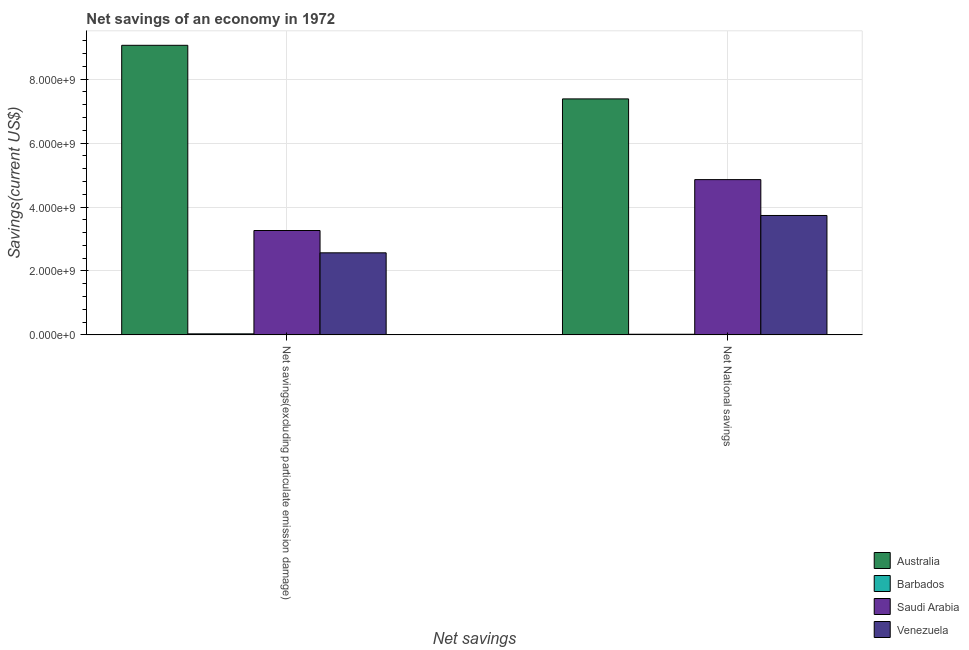How many different coloured bars are there?
Your answer should be compact. 4. How many groups of bars are there?
Provide a succinct answer. 2. Are the number of bars on each tick of the X-axis equal?
Offer a terse response. Yes. How many bars are there on the 2nd tick from the left?
Make the answer very short. 4. How many bars are there on the 2nd tick from the right?
Your response must be concise. 4. What is the label of the 2nd group of bars from the left?
Provide a short and direct response. Net National savings. What is the net savings(excluding particulate emission damage) in Barbados?
Provide a short and direct response. 3.25e+07. Across all countries, what is the maximum net national savings?
Keep it short and to the point. 7.38e+09. Across all countries, what is the minimum net savings(excluding particulate emission damage)?
Offer a terse response. 3.25e+07. In which country was the net savings(excluding particulate emission damage) minimum?
Offer a terse response. Barbados. What is the total net savings(excluding particulate emission damage) in the graph?
Give a very brief answer. 1.49e+1. What is the difference between the net national savings in Australia and that in Venezuela?
Your response must be concise. 3.65e+09. What is the difference between the net national savings in Venezuela and the net savings(excluding particulate emission damage) in Barbados?
Provide a succinct answer. 3.70e+09. What is the average net savings(excluding particulate emission damage) per country?
Provide a succinct answer. 3.73e+09. What is the difference between the net savings(excluding particulate emission damage) and net national savings in Australia?
Offer a terse response. 1.68e+09. In how many countries, is the net savings(excluding particulate emission damage) greater than 8400000000 US$?
Offer a very short reply. 1. What is the ratio of the net national savings in Venezuela to that in Saudi Arabia?
Keep it short and to the point. 0.77. Is the net national savings in Australia less than that in Venezuela?
Your response must be concise. No. In how many countries, is the net national savings greater than the average net national savings taken over all countries?
Give a very brief answer. 2. What does the 3rd bar from the left in Net savings(excluding particulate emission damage) represents?
Your answer should be very brief. Saudi Arabia. What does the 1st bar from the right in Net savings(excluding particulate emission damage) represents?
Your answer should be very brief. Venezuela. How many countries are there in the graph?
Your answer should be compact. 4. What is the difference between two consecutive major ticks on the Y-axis?
Offer a very short reply. 2.00e+09. Are the values on the major ticks of Y-axis written in scientific E-notation?
Provide a succinct answer. Yes. How many legend labels are there?
Your answer should be very brief. 4. What is the title of the graph?
Your response must be concise. Net savings of an economy in 1972. Does "Australia" appear as one of the legend labels in the graph?
Offer a very short reply. Yes. What is the label or title of the X-axis?
Your answer should be very brief. Net savings. What is the label or title of the Y-axis?
Keep it short and to the point. Savings(current US$). What is the Savings(current US$) of Australia in Net savings(excluding particulate emission damage)?
Make the answer very short. 9.06e+09. What is the Savings(current US$) of Barbados in Net savings(excluding particulate emission damage)?
Keep it short and to the point. 3.25e+07. What is the Savings(current US$) of Saudi Arabia in Net savings(excluding particulate emission damage)?
Offer a terse response. 3.27e+09. What is the Savings(current US$) in Venezuela in Net savings(excluding particulate emission damage)?
Ensure brevity in your answer.  2.57e+09. What is the Savings(current US$) of Australia in Net National savings?
Ensure brevity in your answer.  7.38e+09. What is the Savings(current US$) of Barbados in Net National savings?
Offer a very short reply. 2.01e+07. What is the Savings(current US$) of Saudi Arabia in Net National savings?
Your answer should be compact. 4.86e+09. What is the Savings(current US$) in Venezuela in Net National savings?
Your answer should be compact. 3.74e+09. Across all Net savings, what is the maximum Savings(current US$) of Australia?
Make the answer very short. 9.06e+09. Across all Net savings, what is the maximum Savings(current US$) of Barbados?
Keep it short and to the point. 3.25e+07. Across all Net savings, what is the maximum Savings(current US$) in Saudi Arabia?
Offer a very short reply. 4.86e+09. Across all Net savings, what is the maximum Savings(current US$) of Venezuela?
Your response must be concise. 3.74e+09. Across all Net savings, what is the minimum Savings(current US$) of Australia?
Ensure brevity in your answer.  7.38e+09. Across all Net savings, what is the minimum Savings(current US$) of Barbados?
Offer a terse response. 2.01e+07. Across all Net savings, what is the minimum Savings(current US$) in Saudi Arabia?
Provide a short and direct response. 3.27e+09. Across all Net savings, what is the minimum Savings(current US$) of Venezuela?
Offer a terse response. 2.57e+09. What is the total Savings(current US$) of Australia in the graph?
Make the answer very short. 1.64e+1. What is the total Savings(current US$) in Barbados in the graph?
Give a very brief answer. 5.26e+07. What is the total Savings(current US$) of Saudi Arabia in the graph?
Your response must be concise. 8.12e+09. What is the total Savings(current US$) of Venezuela in the graph?
Provide a succinct answer. 6.30e+09. What is the difference between the Savings(current US$) of Australia in Net savings(excluding particulate emission damage) and that in Net National savings?
Your answer should be very brief. 1.68e+09. What is the difference between the Savings(current US$) of Barbados in Net savings(excluding particulate emission damage) and that in Net National savings?
Your answer should be very brief. 1.24e+07. What is the difference between the Savings(current US$) of Saudi Arabia in Net savings(excluding particulate emission damage) and that in Net National savings?
Make the answer very short. -1.59e+09. What is the difference between the Savings(current US$) in Venezuela in Net savings(excluding particulate emission damage) and that in Net National savings?
Your response must be concise. -1.17e+09. What is the difference between the Savings(current US$) of Australia in Net savings(excluding particulate emission damage) and the Savings(current US$) of Barbados in Net National savings?
Provide a short and direct response. 9.04e+09. What is the difference between the Savings(current US$) in Australia in Net savings(excluding particulate emission damage) and the Savings(current US$) in Saudi Arabia in Net National savings?
Offer a very short reply. 4.20e+09. What is the difference between the Savings(current US$) in Australia in Net savings(excluding particulate emission damage) and the Savings(current US$) in Venezuela in Net National savings?
Your response must be concise. 5.32e+09. What is the difference between the Savings(current US$) in Barbados in Net savings(excluding particulate emission damage) and the Savings(current US$) in Saudi Arabia in Net National savings?
Provide a succinct answer. -4.83e+09. What is the difference between the Savings(current US$) of Barbados in Net savings(excluding particulate emission damage) and the Savings(current US$) of Venezuela in Net National savings?
Your answer should be very brief. -3.70e+09. What is the difference between the Savings(current US$) in Saudi Arabia in Net savings(excluding particulate emission damage) and the Savings(current US$) in Venezuela in Net National savings?
Make the answer very short. -4.70e+08. What is the average Savings(current US$) in Australia per Net savings?
Your answer should be compact. 8.22e+09. What is the average Savings(current US$) in Barbados per Net savings?
Give a very brief answer. 2.63e+07. What is the average Savings(current US$) in Saudi Arabia per Net savings?
Provide a short and direct response. 4.06e+09. What is the average Savings(current US$) in Venezuela per Net savings?
Offer a very short reply. 3.15e+09. What is the difference between the Savings(current US$) of Australia and Savings(current US$) of Barbados in Net savings(excluding particulate emission damage)?
Make the answer very short. 9.03e+09. What is the difference between the Savings(current US$) of Australia and Savings(current US$) of Saudi Arabia in Net savings(excluding particulate emission damage)?
Offer a terse response. 5.79e+09. What is the difference between the Savings(current US$) in Australia and Savings(current US$) in Venezuela in Net savings(excluding particulate emission damage)?
Keep it short and to the point. 6.49e+09. What is the difference between the Savings(current US$) in Barbados and Savings(current US$) in Saudi Arabia in Net savings(excluding particulate emission damage)?
Your answer should be compact. -3.23e+09. What is the difference between the Savings(current US$) in Barbados and Savings(current US$) in Venezuela in Net savings(excluding particulate emission damage)?
Make the answer very short. -2.53e+09. What is the difference between the Savings(current US$) in Saudi Arabia and Savings(current US$) in Venezuela in Net savings(excluding particulate emission damage)?
Give a very brief answer. 6.98e+08. What is the difference between the Savings(current US$) in Australia and Savings(current US$) in Barbados in Net National savings?
Keep it short and to the point. 7.36e+09. What is the difference between the Savings(current US$) of Australia and Savings(current US$) of Saudi Arabia in Net National savings?
Offer a very short reply. 2.53e+09. What is the difference between the Savings(current US$) in Australia and Savings(current US$) in Venezuela in Net National savings?
Make the answer very short. 3.65e+09. What is the difference between the Savings(current US$) of Barbados and Savings(current US$) of Saudi Arabia in Net National savings?
Offer a terse response. -4.84e+09. What is the difference between the Savings(current US$) in Barbados and Savings(current US$) in Venezuela in Net National savings?
Provide a short and direct response. -3.72e+09. What is the difference between the Savings(current US$) in Saudi Arabia and Savings(current US$) in Venezuela in Net National savings?
Keep it short and to the point. 1.12e+09. What is the ratio of the Savings(current US$) in Australia in Net savings(excluding particulate emission damage) to that in Net National savings?
Your response must be concise. 1.23. What is the ratio of the Savings(current US$) of Barbados in Net savings(excluding particulate emission damage) to that in Net National savings?
Keep it short and to the point. 1.62. What is the ratio of the Savings(current US$) of Saudi Arabia in Net savings(excluding particulate emission damage) to that in Net National savings?
Your response must be concise. 0.67. What is the ratio of the Savings(current US$) in Venezuela in Net savings(excluding particulate emission damage) to that in Net National savings?
Provide a succinct answer. 0.69. What is the difference between the highest and the second highest Savings(current US$) in Australia?
Provide a succinct answer. 1.68e+09. What is the difference between the highest and the second highest Savings(current US$) in Barbados?
Provide a succinct answer. 1.24e+07. What is the difference between the highest and the second highest Savings(current US$) in Saudi Arabia?
Your answer should be very brief. 1.59e+09. What is the difference between the highest and the second highest Savings(current US$) of Venezuela?
Make the answer very short. 1.17e+09. What is the difference between the highest and the lowest Savings(current US$) of Australia?
Provide a short and direct response. 1.68e+09. What is the difference between the highest and the lowest Savings(current US$) of Barbados?
Give a very brief answer. 1.24e+07. What is the difference between the highest and the lowest Savings(current US$) of Saudi Arabia?
Make the answer very short. 1.59e+09. What is the difference between the highest and the lowest Savings(current US$) of Venezuela?
Make the answer very short. 1.17e+09. 